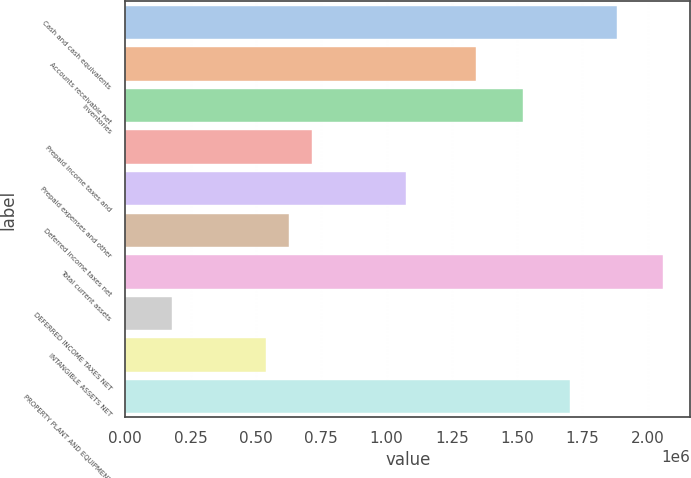Convert chart to OTSL. <chart><loc_0><loc_0><loc_500><loc_500><bar_chart><fcel>Cash and cash equivalents<fcel>Accounts receivable net<fcel>Inventories<fcel>Prepaid income taxes and<fcel>Prepaid expenses and other<fcel>Deferred income taxes net<fcel>Total current assets<fcel>DEFERRED INCOME TAXES NET<fcel>INTANGIBLE ASSETS NET<fcel>PROPERTY PLANT AND EQUIPMENT<nl><fcel>1.88054e+06<fcel>1.34324e+06<fcel>1.52234e+06<fcel>716399<fcel>1.0746e+06<fcel>626850<fcel>2.05964e+06<fcel>179104<fcel>537301<fcel>1.70144e+06<nl></chart> 